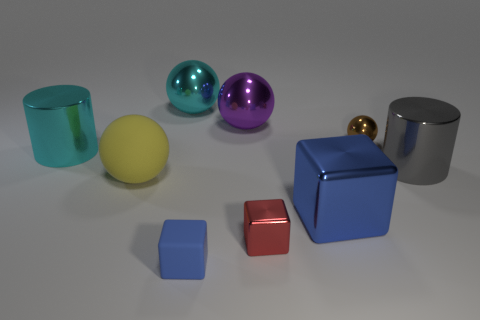What color is the big cube?
Offer a terse response. Blue. There is a big cyan shiny object that is left of the big yellow matte ball; is there a tiny object that is in front of it?
Ensure brevity in your answer.  Yes. How many rubber objects have the same size as the purple metal thing?
Keep it short and to the point. 1. How many blue metallic cubes are behind the cylinder that is to the left of the shiny cylinder that is on the right side of the yellow sphere?
Your response must be concise. 0. How many things are to the left of the large blue metallic cube and in front of the big purple shiny sphere?
Offer a very short reply. 4. Are there any other things that have the same color as the big matte thing?
Your answer should be compact. No. How many matte things are either purple objects or small spheres?
Offer a very short reply. 0. The big cylinder that is to the left of the big gray metal thing that is on the right side of the small thing behind the big matte object is made of what material?
Offer a very short reply. Metal. The large cylinder that is on the left side of the large shiny cylinder that is to the right of the yellow rubber ball is made of what material?
Your answer should be very brief. Metal. There is a yellow matte sphere in front of the large cyan cylinder; is it the same size as the cylinder on the right side of the big block?
Offer a very short reply. Yes. 